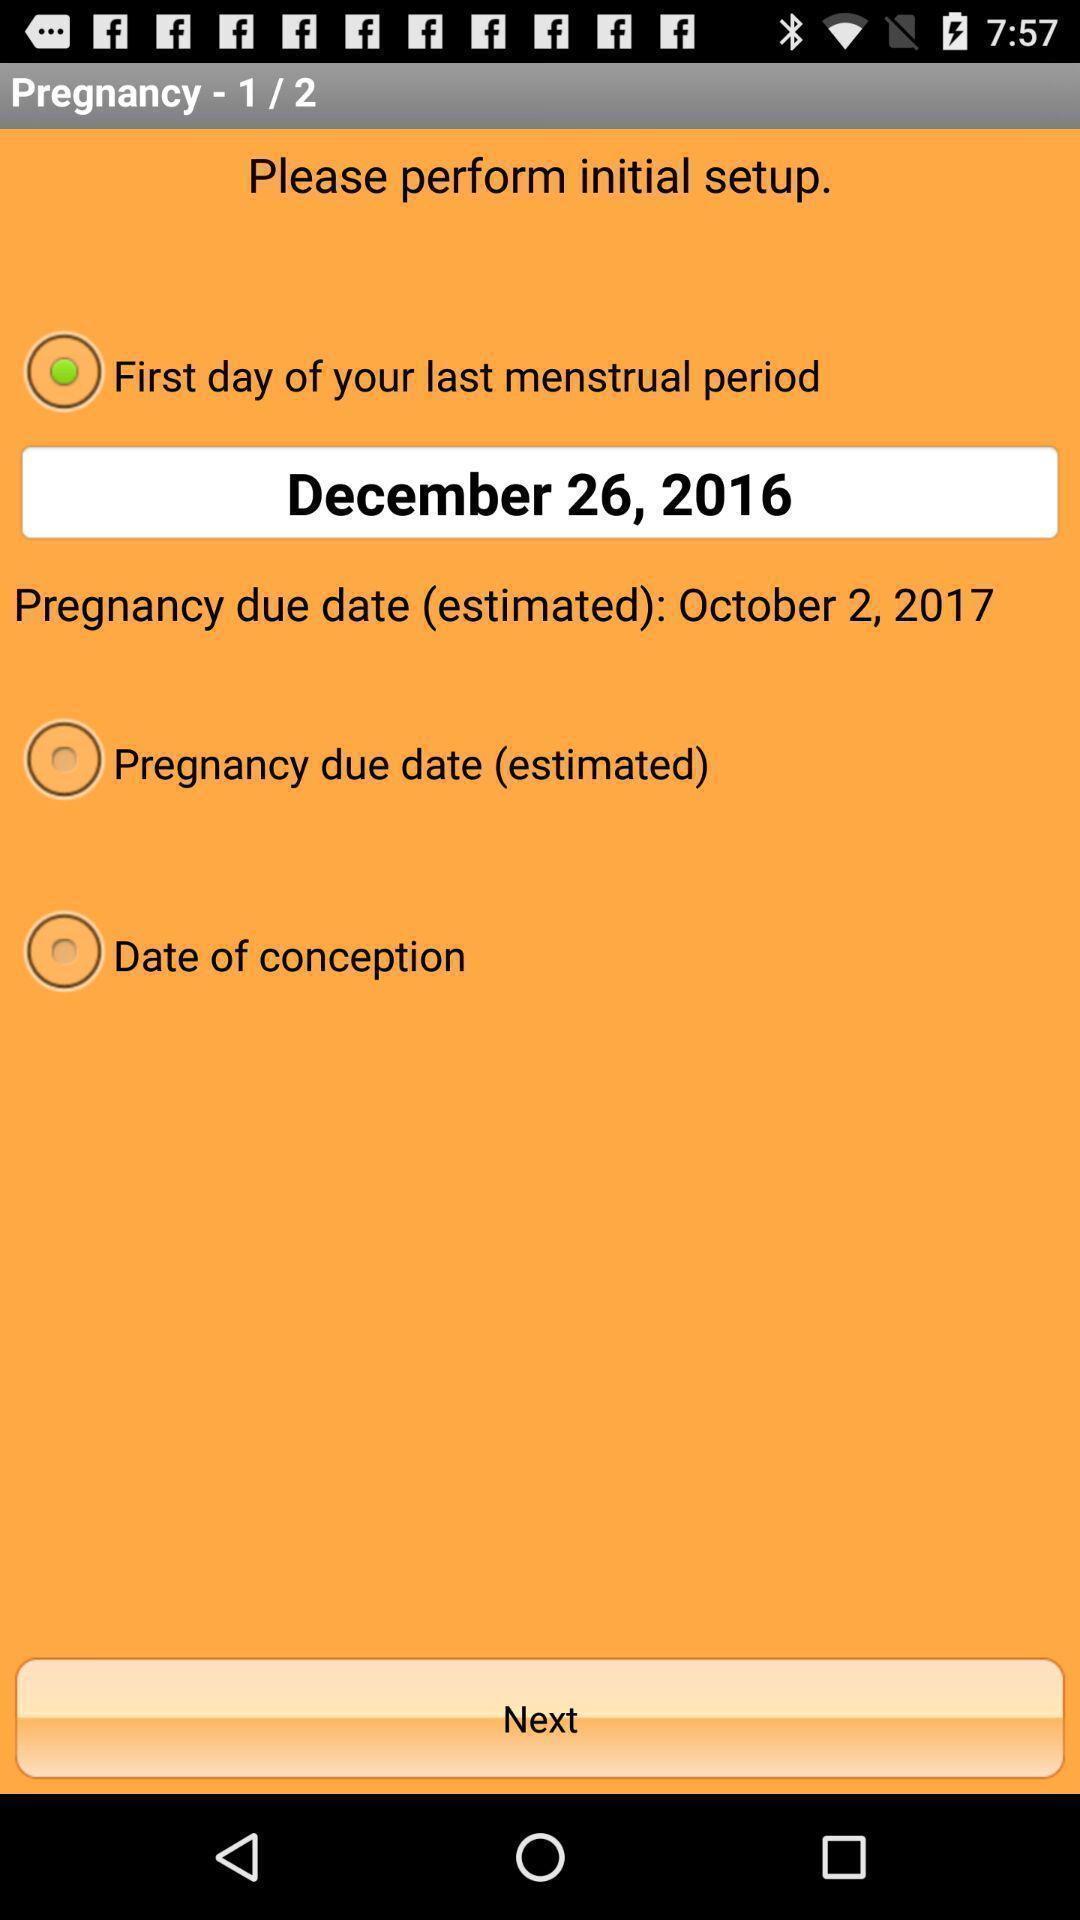Provide a detailed account of this screenshot. Setup page of a period tracker app. 